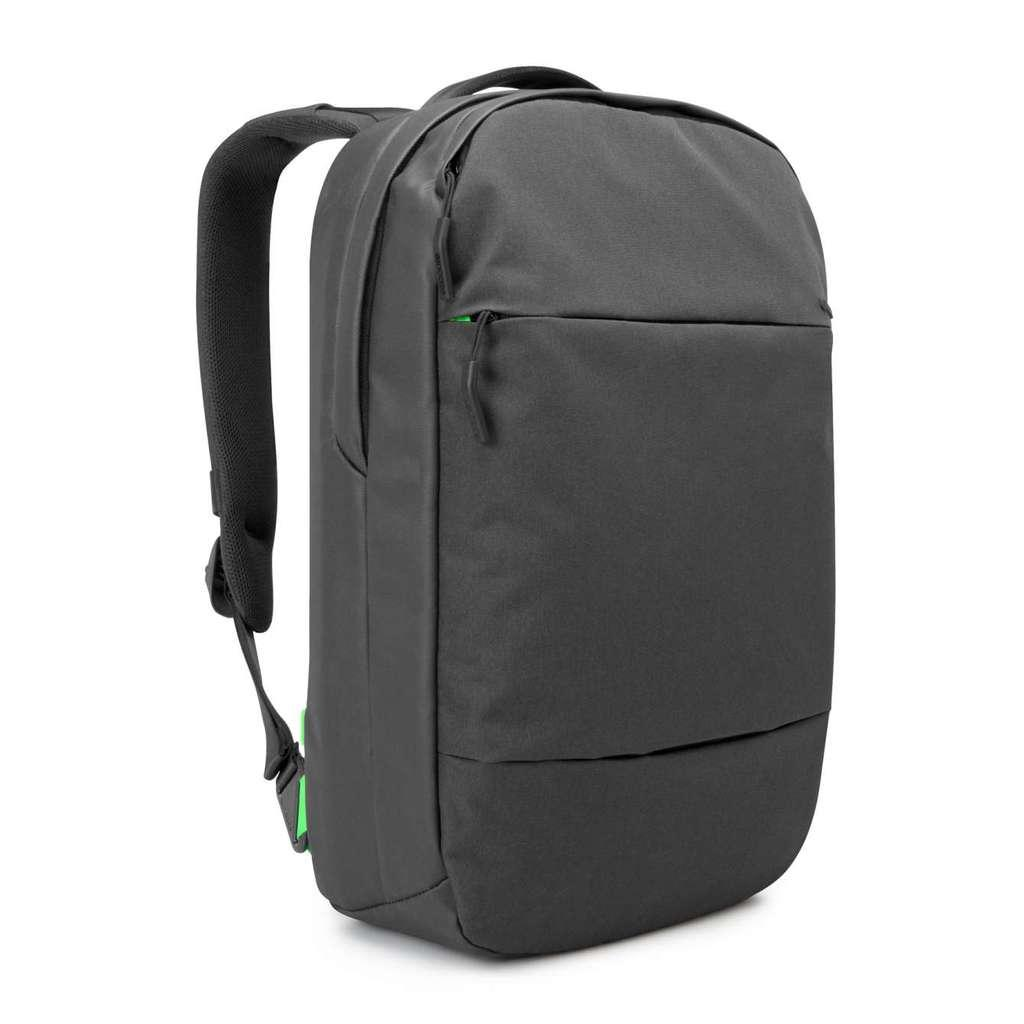What object can be seen in the image? There is a backpack in the image. What is the color of the backpack? The backpack is black in color. How does the bread rub against the backpack in the image? There is no bread present in the image, so it cannot rub against the backpack. 